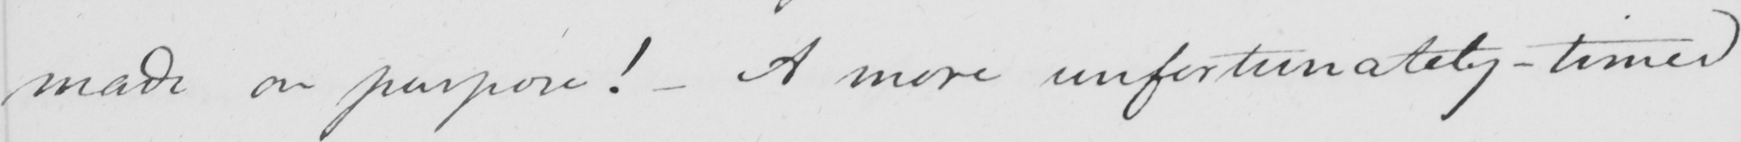Please provide the text content of this handwritten line. made on purpose !   _  A more unfortunately-timed 